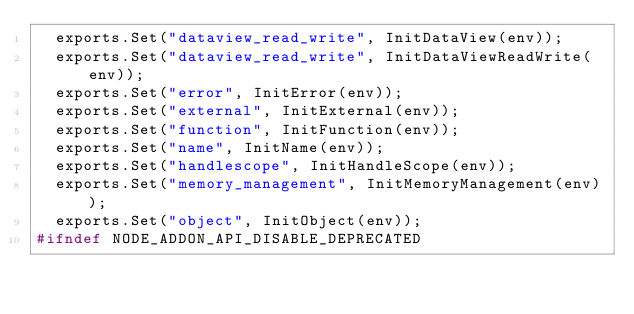<code> <loc_0><loc_0><loc_500><loc_500><_C++_>  exports.Set("dataview_read_write", InitDataView(env));
  exports.Set("dataview_read_write", InitDataViewReadWrite(env));
  exports.Set("error", InitError(env));
  exports.Set("external", InitExternal(env));
  exports.Set("function", InitFunction(env));
  exports.Set("name", InitName(env));
  exports.Set("handlescope", InitHandleScope(env));
  exports.Set("memory_management", InitMemoryManagement(env));
  exports.Set("object", InitObject(env));
#ifndef NODE_ADDON_API_DISABLE_DEPRECATED</code> 